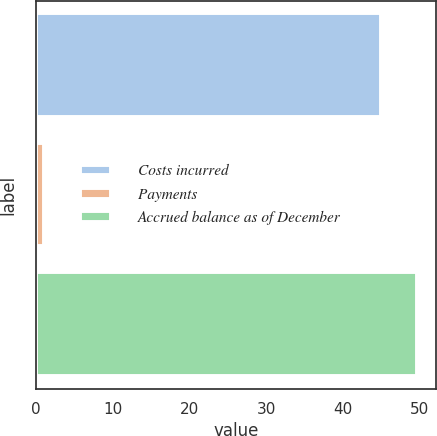<chart> <loc_0><loc_0><loc_500><loc_500><bar_chart><fcel>Costs incurred<fcel>Payments<fcel>Accrued balance as of December<nl><fcel>45<fcel>1<fcel>49.7<nl></chart> 